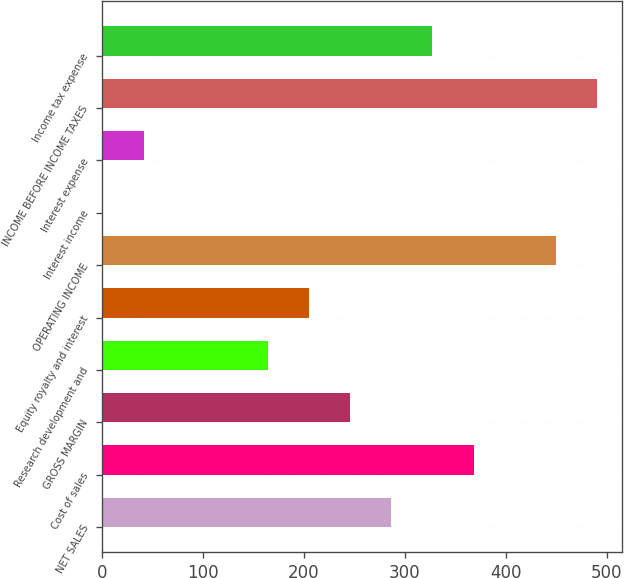<chart> <loc_0><loc_0><loc_500><loc_500><bar_chart><fcel>NET SALES<fcel>Cost of sales<fcel>GROSS MARGIN<fcel>Research development and<fcel>Equity royalty and interest<fcel>OPERATING INCOME<fcel>Interest income<fcel>Interest expense<fcel>INCOME BEFORE INCOME TAXES<fcel>Income tax expense<nl><fcel>286.6<fcel>368.2<fcel>245.8<fcel>164.2<fcel>205<fcel>449.8<fcel>1<fcel>41.8<fcel>490.6<fcel>327.4<nl></chart> 